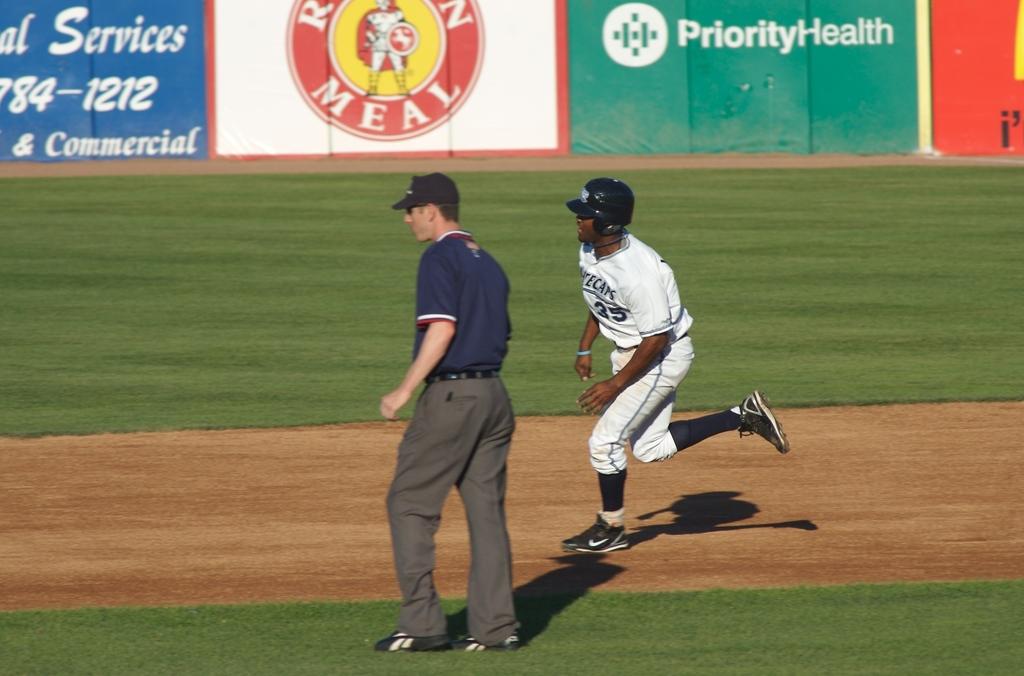What companies sponsor this event?
Give a very brief answer. Priority health. What are the last four digits of the phone number shown?
Ensure brevity in your answer.  1212. 